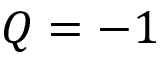Convert formula to latex. <formula><loc_0><loc_0><loc_500><loc_500>Q = - 1</formula> 